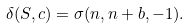Convert formula to latex. <formula><loc_0><loc_0><loc_500><loc_500>\delta ( S , c ) = \sigma ( n , n + b , - 1 ) .</formula> 